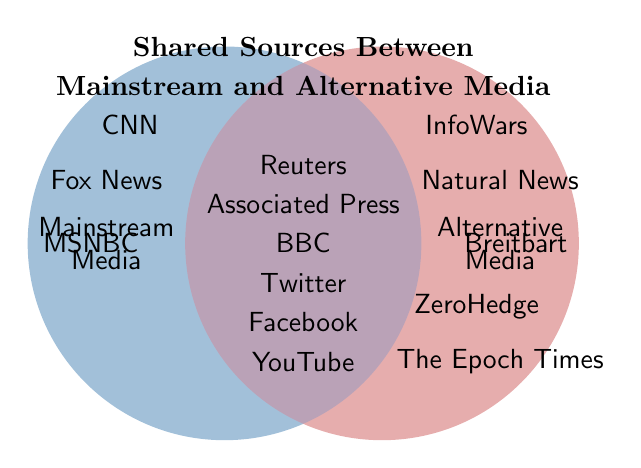Which media sources are common to both mainstream and alternative media? From the overlapping area of the Venn diagram, we see the common sources listed, those being Reuters, Associated Press, BBC, Twitter, Facebook, and YouTube.
Answer: Reuters, Associated Press, BBC, Twitter, Facebook, YouTube Which media sources only belong to mainstream media? The sources located in the left (blue) circle that do not overlap with the right circle are the ones exclusive to mainstream media. These sources are CNN, Fox News, and MSNBC.
Answer: CNN, Fox News, MSNBC Which media sources are unique to alternative media? The sources located in the right (red) circle that do not overlap with the left circle are exclusive to alternative media. These sources are InfoWars, Natural News, Breitbart, ZeroHedge, and The Epoch Times.
Answer: InfoWars, Natural News, Breitbart, ZeroHedge, The Epoch Times How many media sources in total are shared between mainstream and alternative media? Count the number of sources in the overlapping area of the Venn diagram. There are six shared sources listed.
Answer: 6 Compare the number of unique sources in mainstream media with those in alternative media. Count the unique sources for each: mainstream has three sources (CNN, Fox News, MSNBC), and alternative media has five sources (InfoWars, Natural News, Breitbart, ZeroHedge, The Epoch Times). Therefore, alternative media has more unique sources than mainstream media.
Answer: Alternative media has more (5 vs. 3) Are there more shared sources or alternative-only sources? Compare the number of shared sources (6) with alternative-only sources (5). Since 6 is greater than 5, there are more shared sources.
Answer: Shared sources are more (6 vs. 5) Which shared source is also a social media platform? From the overlapping sources, the social media platforms listed are Twitter, Facebook, and YouTube.
Answer: Twitter, Facebook, YouTube Is Reuters present in mainstream media, alternative media, or both? Reuters is located in the overlapping area of the Venn diagram, indicating it is shared by both mainstream and alternative media.
Answer: Both How many sources are unique to alternative media? Count the number of alternative-only sources located in the right circle. There are five unique sources listed.
Answer: 5 